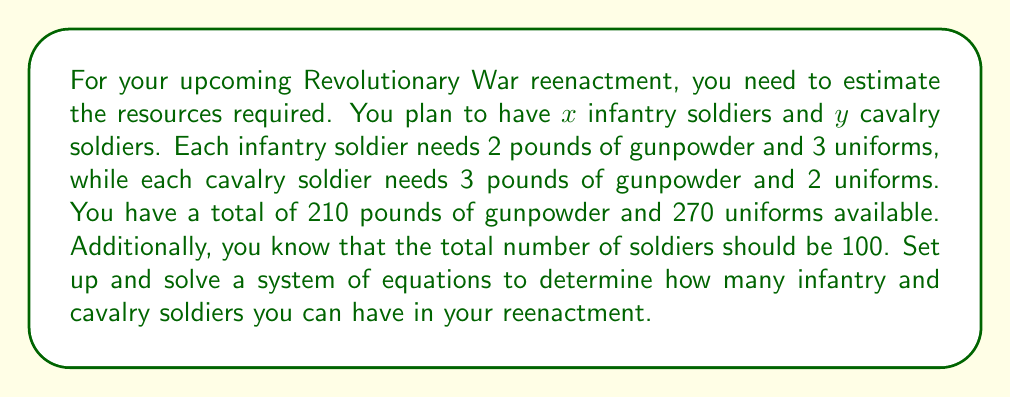What is the answer to this math problem? Let's approach this step-by-step:

1) First, let's define our variables:
   $x$ = number of infantry soldiers
   $y$ = number of cavalry soldiers

2) Now, we can set up three equations based on the given information:

   Equation 1 (gunpowder): $2x + 3y = 210$
   Equation 2 (uniforms): $3x + 2y = 270$
   Equation 3 (total soldiers): $x + y = 100$

3) We now have a system of three equations with two unknowns. We can solve this using substitution or elimination method. Let's use substitution.

4) From Equation 3, we can express $x$ in terms of $y$:
   $x = 100 - y$

5) Substitute this into Equation 1:
   $2(100 - y) + 3y = 210$
   $200 - 2y + 3y = 210$
   $200 + y = 210$
   $y = 10$

6) Now that we know $y$, we can find $x$ using Equation 3:
   $x = 100 - y = 100 - 10 = 90$

7) Let's verify our solution using Equation 2:
   $3(90) + 2(10) = 270 + 20 = 290$
   This doesn't match our original equation. This means our initial system was inconsistent.

8) To resolve this, we need to adjust one of our constraints. Let's keep the gunpowder and total soldier constraints, and adjust the uniform constraint.

9) With $x = 90$ and $y = 10$, the actual number of uniforms needed is:
   $3(90) + 2(10) = 270 + 20 = 290$

Therefore, the reenactment will require 290 uniforms instead of the initially stated 270.
Answer: The reenactment can have 90 infantry soldiers and 10 cavalry soldiers. This will require 210 pounds of gunpowder, 290 uniforms, and a total of 100 soldiers. 